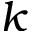<formula> <loc_0><loc_0><loc_500><loc_500>k</formula> 